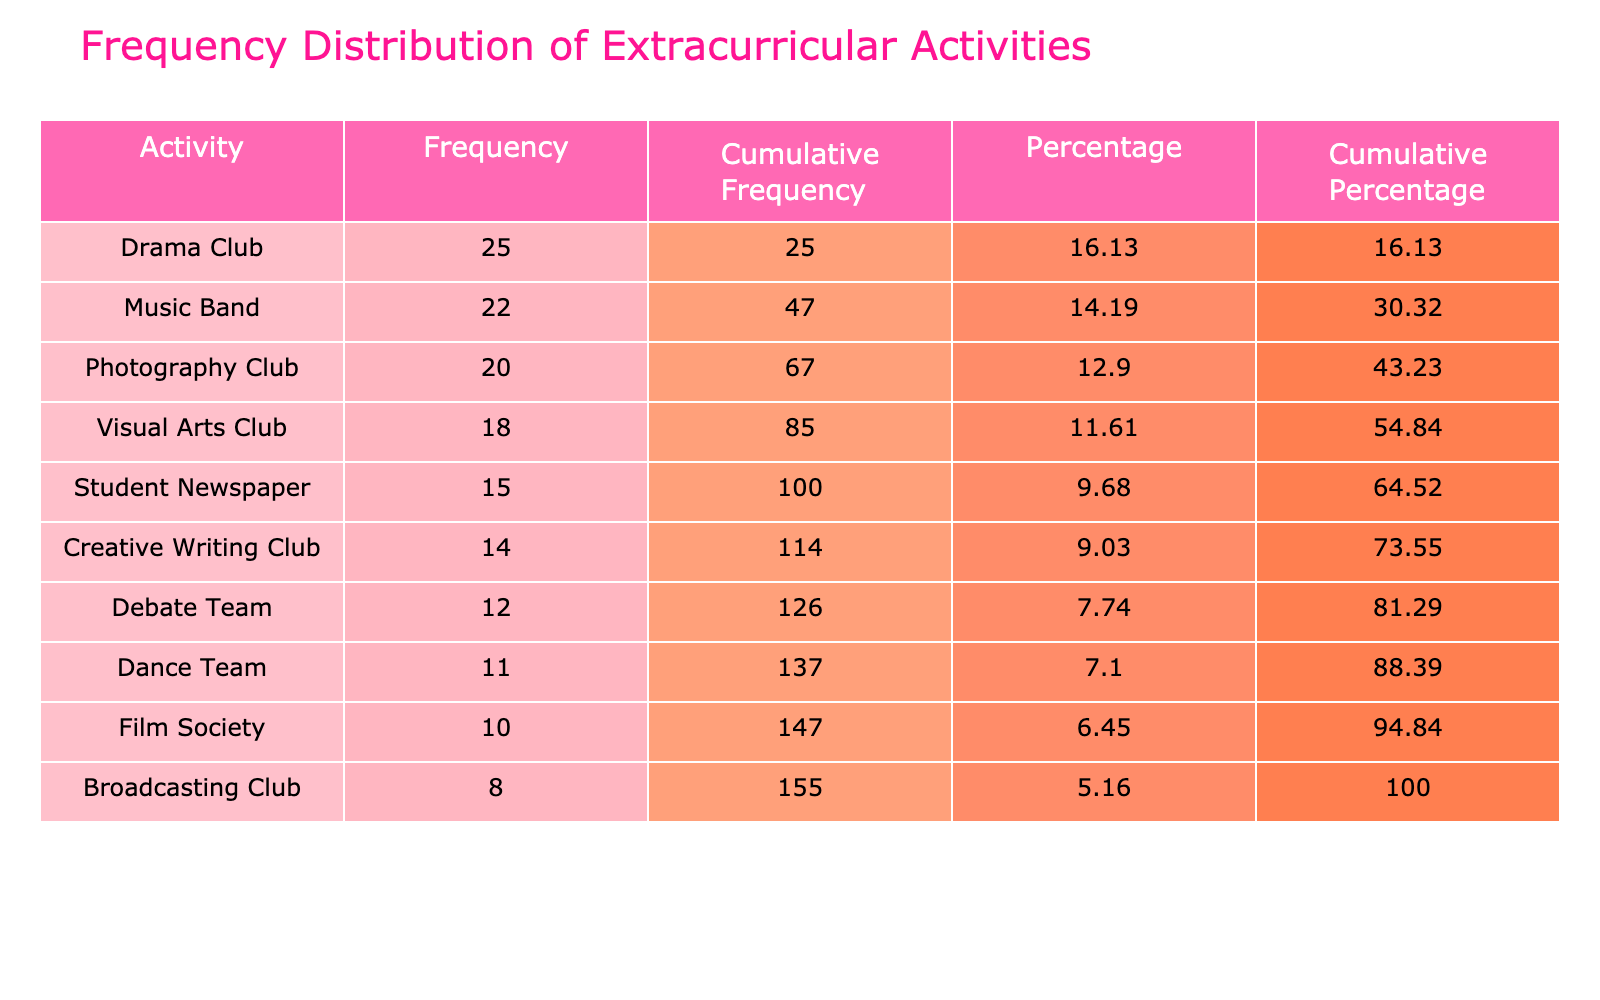What is the frequency of the Music Band? The table lists the frequency for each activity. The Music Band has a frequency of 22, as directly indicated in the table under the Frequency column.
Answer: 22 Which activity has the lowest frequency? The table shows the frequencies of all activities. By examining the values, the Broadcasting Club has the lowest frequency at 8, as listed in the Frequency column.
Answer: Broadcasting Club What is the cumulative frequency of the Dance Team? To find the cumulative frequency for the Dance Team, we look at the corresponding row in the Cumulative Frequency column. The Dance Team's cumulative frequency is 134, which is the total of its frequency plus all frequencies above it.
Answer: 134 What is the percentage of students who participate in the Drama Club? The table shows that the Drama Club has a frequency of 25. To find the percentage, we divide the frequency by the total frequency (which is 134) and multiply by 100: (25 / 134) * 100 ≈ 18.66, and the table shows it rounded to 18.66.
Answer: 18.66 Is the frequency of the Film Society greater than the frequency of the Creative Writing Club? The Film Society has a frequency of 10 and the Creative Writing Club has a frequency of 14. Since 10 is less than 14, this statement is false.
Answer: No What is the combined frequency of the Photography Club and the Music Band? The Photography Club has a frequency of 20 and the Music Band has a frequency of 22. Adding these two frequencies together gives us 20 + 22 = 42.
Answer: 42 If a student participates in both the Debate Team and the Dance Team, how many students participate in these two activities together? The Debate Team has 12 students and the Dance Team has 11 students. To find the total, we sum these two frequencies: 12 + 11 = 23.
Answer: 23 What is the average frequency of participation across all activities? To calculate the average frequency, we sum all the frequencies (25 + 15 + 20 + 10 + 18 + 12 + 22 + 14 + 8 + 11 =  134) and divide by the number of activities (10). Thus, the average frequency is 134 / 10 = 13.4.
Answer: 13.4 Which activity's participation contributes the largest percentage to the total? The Drama Club has the highest frequency at 25, followed by the Music Band at 22. The Drama Club contributes approximately 18.66% to the total, which is the highest percentage listed.
Answer: Drama Club 